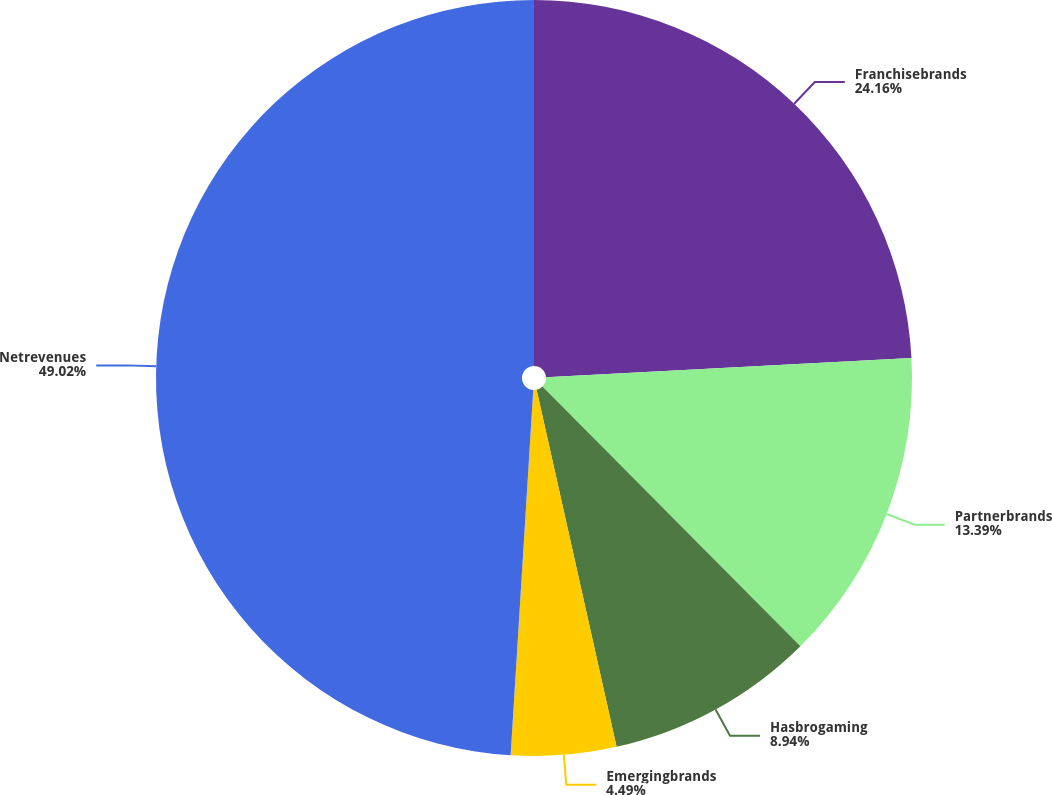<chart> <loc_0><loc_0><loc_500><loc_500><pie_chart><fcel>Franchisebrands<fcel>Partnerbrands<fcel>Hasbrogaming<fcel>Emergingbrands<fcel>Netrevenues<nl><fcel>24.16%<fcel>13.39%<fcel>8.94%<fcel>4.49%<fcel>49.01%<nl></chart> 